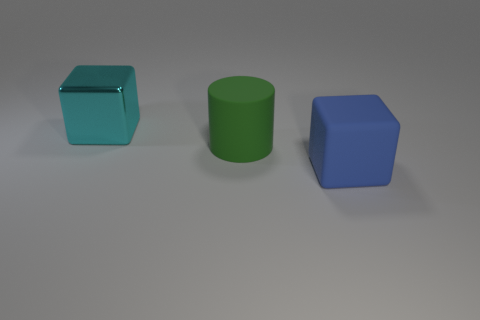Are there any other things that are made of the same material as the big cyan thing?
Keep it short and to the point. No. Is the number of blue objects to the right of the blue object greater than the number of matte cubes that are on the left side of the cyan shiny object?
Provide a succinct answer. No. Is the color of the big rubber cylinder the same as the large object behind the big green rubber cylinder?
Offer a very short reply. No. What is the material of the cyan block that is the same size as the cylinder?
Your response must be concise. Metal. How many objects are either large gray balls or big cubes right of the cyan metal object?
Make the answer very short. 1. Do the matte cylinder and the cube that is behind the large green object have the same size?
Your answer should be compact. Yes. How many cylinders are large yellow objects or big shiny things?
Your response must be concise. 0. How many objects are both on the right side of the big metal thing and behind the blue block?
Ensure brevity in your answer.  1. What number of other objects are there of the same color as the large cylinder?
Your answer should be compact. 0. What is the shape of the large thing right of the cylinder?
Your answer should be compact. Cube. 